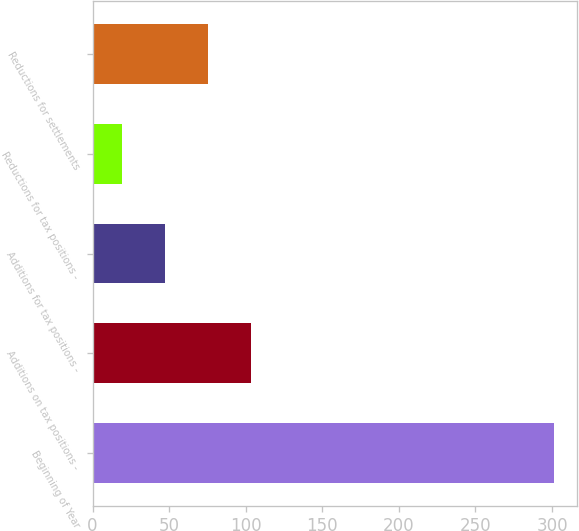<chart> <loc_0><loc_0><loc_500><loc_500><bar_chart><fcel>Beginning of Year<fcel>Additions on tax positions -<fcel>Additions for tax positions -<fcel>Reductions for tax positions -<fcel>Reductions for settlements<nl><fcel>301<fcel>103.6<fcel>47.2<fcel>19<fcel>75.4<nl></chart> 